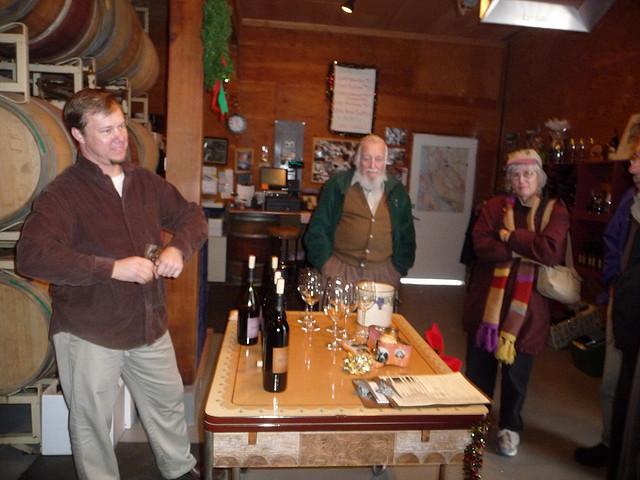What kind of uniform is the lady wearing?
Keep it brief. None. What do the barrels likely hold?
Concise answer only. Wine. What are the people getting ready to taste?
Be succinct. Wine. Have the bottles been opened?
Short answer required. No. How many horseshoes do you see?
Keep it brief. 0. Are they drinking the wine?
Write a very short answer. Yes. Where are the wine bottles?
Quick response, please. On table. 